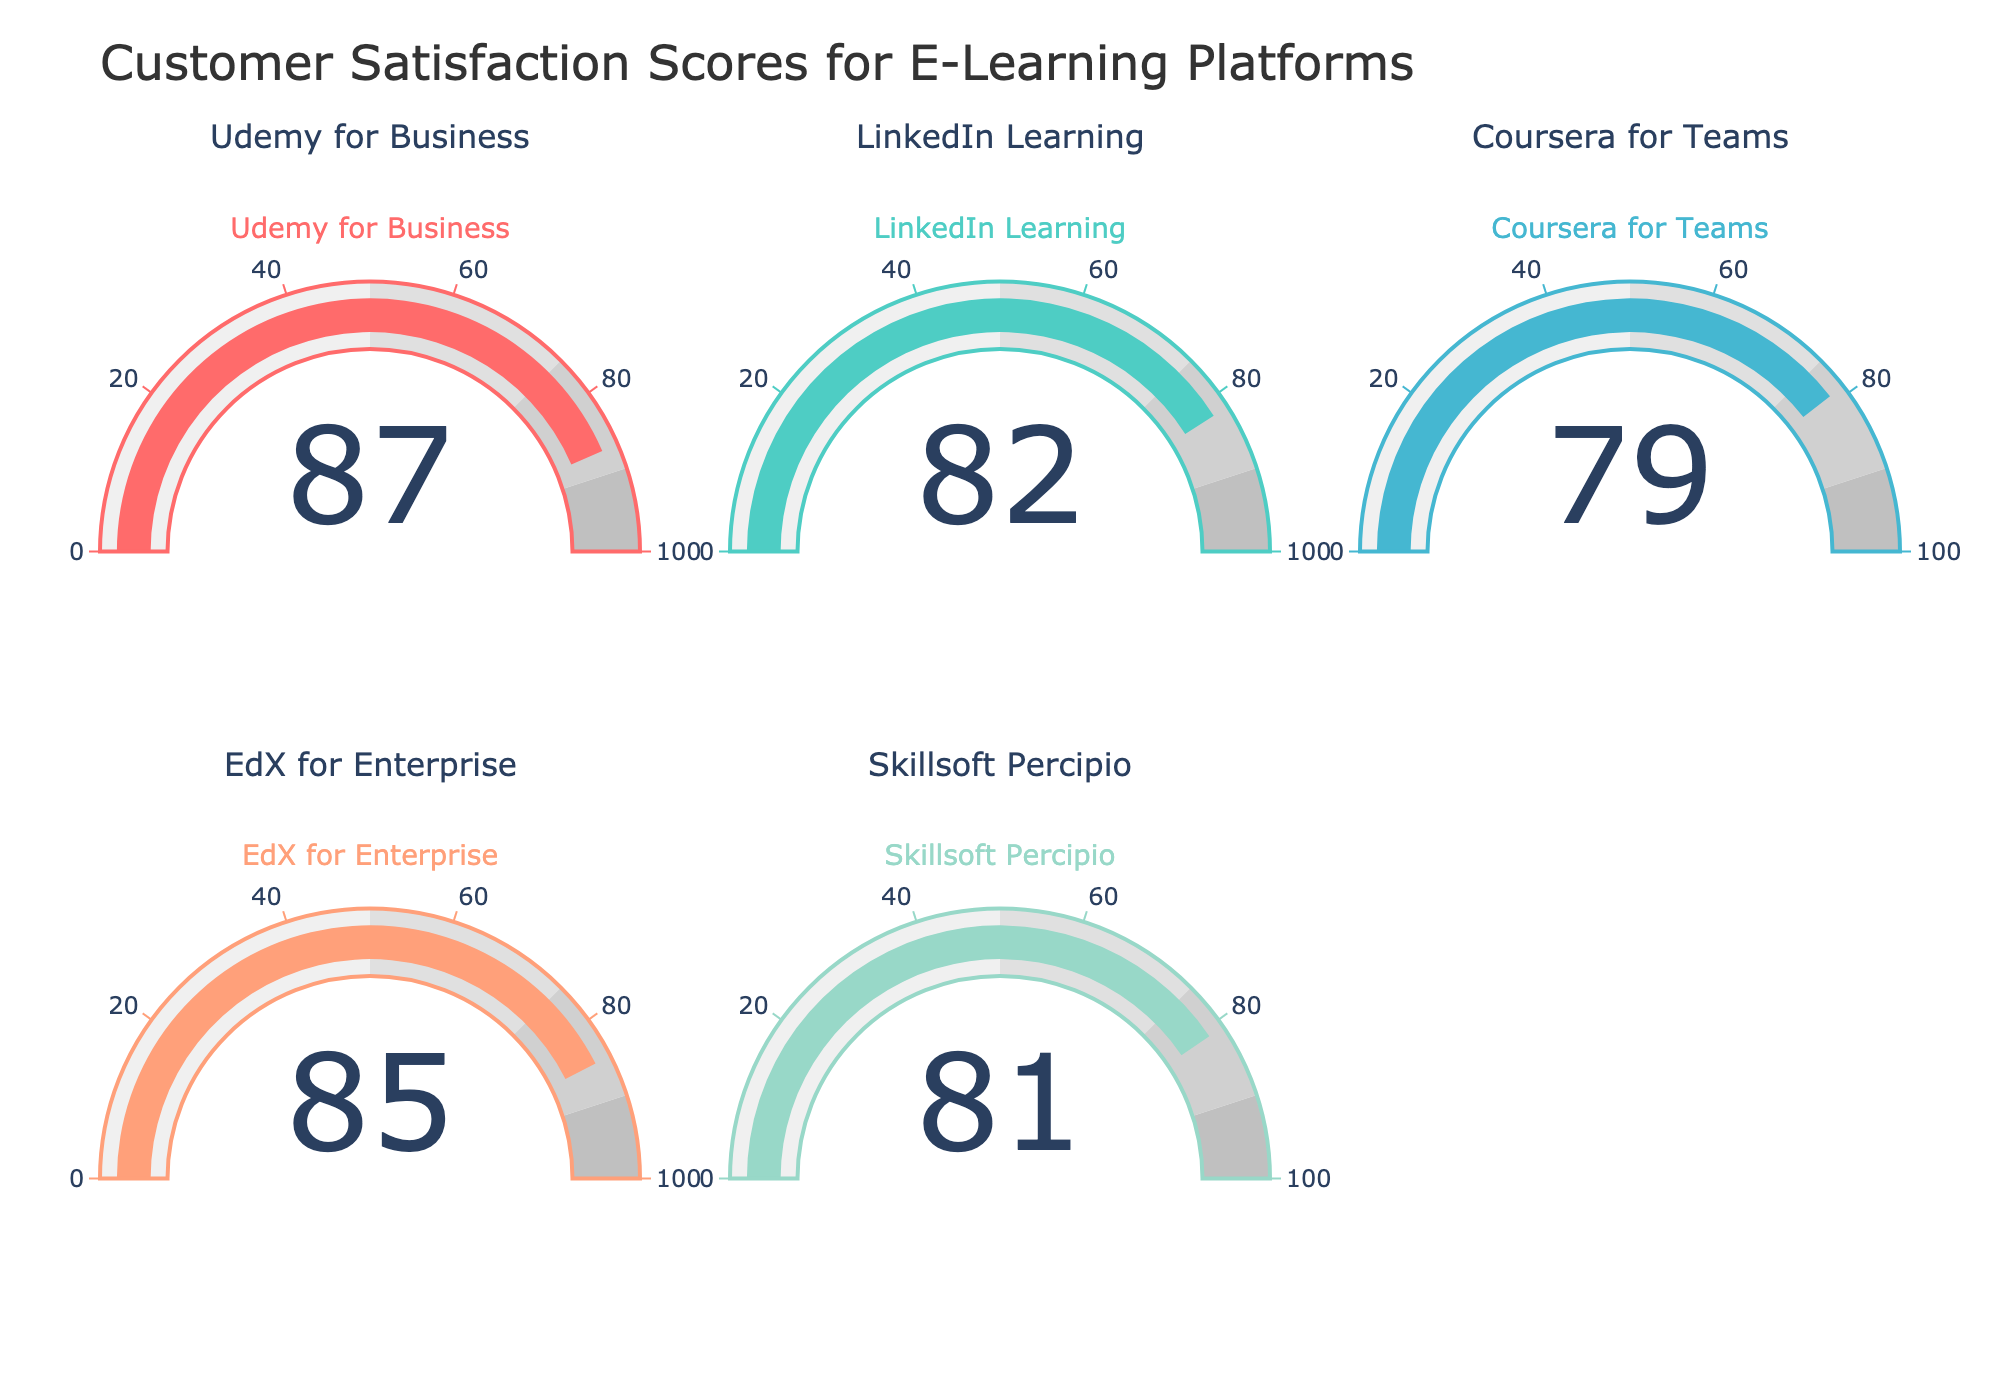What is the title of the gauge chart figure? The title is displayed at the top of the figure. It reads "Customer Satisfaction Scores for E-Learning Platforms".
Answer: Customer Satisfaction Scores for E-Learning Platforms Which e-learning platform has the highest customer satisfaction score? By looking at the gauges, Udemy for Business has the highest value indicated, which is 87.
Answer: Udemy for Business How many e-learning platforms are displayed in the figure? There are five subplots/gauges shown, each representing a different e-learning platform: Udemy for Business, LinkedIn Learning, Coursera for Teams, EdX for Enterprise, and Skillsoft Percipio.
Answer: 5 What is the average customer satisfaction score of all the e-learning platforms? The scores are 87, 82, 79, 85, and 81. Add them up to get 414. Divide by the number of platforms (5) to get the average: 414 / 5 = 82.8
Answer: 82.8 Which e-learning platform has a customer satisfaction score closest to 80? Looking at the scores, Coursera for Teams has the score closest to 80, which is 79.
Answer: Coursera for Teams What is the difference in customer satisfaction score between EdX for Enterprise and Skillsoft Percipio? EdX for Enterprise has a score of 85, while Skillsoft Percipio has a score of 81. The difference is calculated as 85 - 81 = 4.
Answer: 4 Is LinkedIn Learning’s customer satisfaction score greater than Coursera for Teams? LinkedIn Learning has a score of 82, and Coursera for Teams has a score of 79. 82 is greater than 79.
Answer: Yes What is the range of customer satisfaction scores among the e-learning platforms? The lowest score is 79 (Coursera for Teams) and the highest is 87 (Udemy for Business). The range is calculated as 87 - 79 = 8.
Answer: 8 Are any of the e-learning platforms' customer satisfaction scores in the [75, 90] interval? All the platforms' scores (87, 82, 79, 85, and 81) fall within the 75 to 90 range. Therefore, all platforms are in this interval.
Answer: Yes Which platform has a score just below EdX for Enterprise? Based on the scores, Skillsoft Percipio has the score just below EdX for Enterprise, with a score of 81, compared to EdX’s score of 85.
Answer: Skillsoft Percipio 